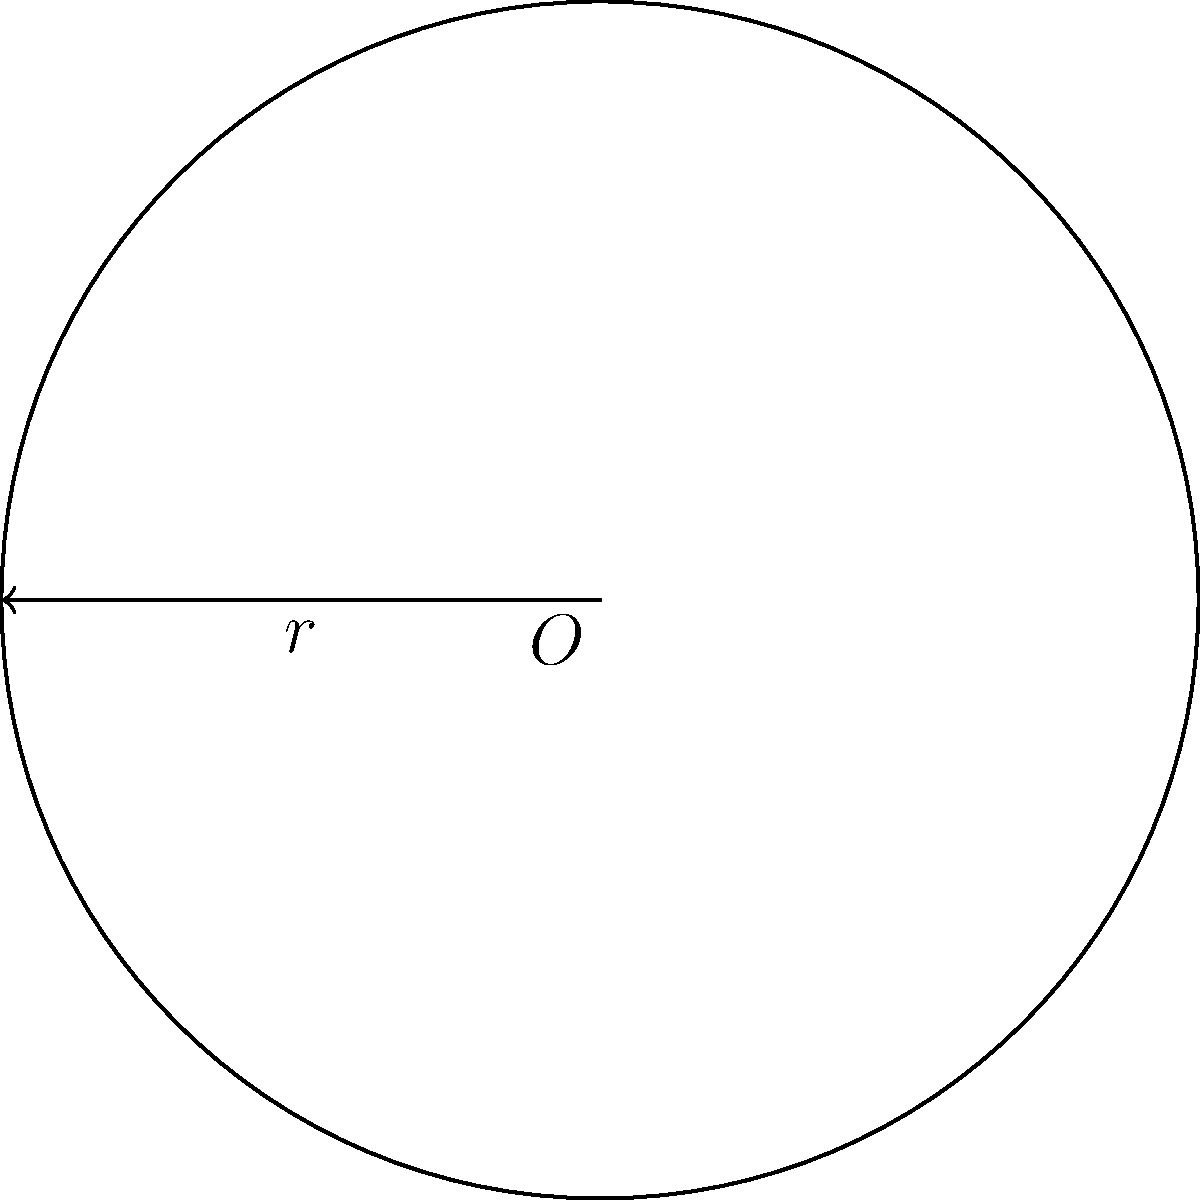In our collaborative project, we need to calculate the circumference of a circular component. Given that the radius of this component is 5 units, what would be its circumference? Let's work through this together and discuss how we can apply this calculation to optimize our design process. Let's approach this step-by-step:

1) The formula for the circumference of a circle is:
   
   $$C = 2\pi r$$

   where $C$ is the circumference, $\pi$ is pi (approximately 3.14159), and $r$ is the radius.

2) We're given that the radius is 5 units. Let's substitute this into our formula:

   $$C = 2\pi (5)$$

3) Now, let's multiply:

   $$C = 10\pi$$

4) We could leave our answer like this, or we could calculate an approximate value. Let's do both:

   $$C = 10\pi \approx 10 * 3.14159 \approx 31.4159$$

5) Therefore, the circumference is $10\pi$ units, or approximately 31.4159 units.

In our project, we can use this calculation to determine the amount of material needed for the circular component, or to calculate how long it would take for an object to travel around this circle at a given speed. How do you think we could apply this in other aspects of our design?
Answer: $10\pi$ units (or approximately 31.4159 units) 